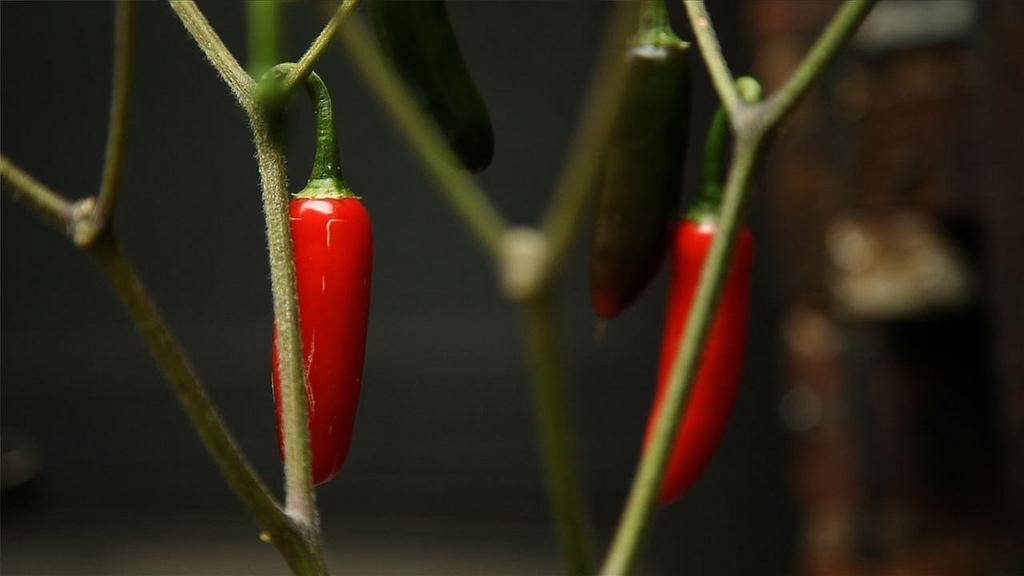How would you summarize this image in a sentence or two? This image consists of red chilies which are hanged to the stem of a plant. The stems are in green color. 